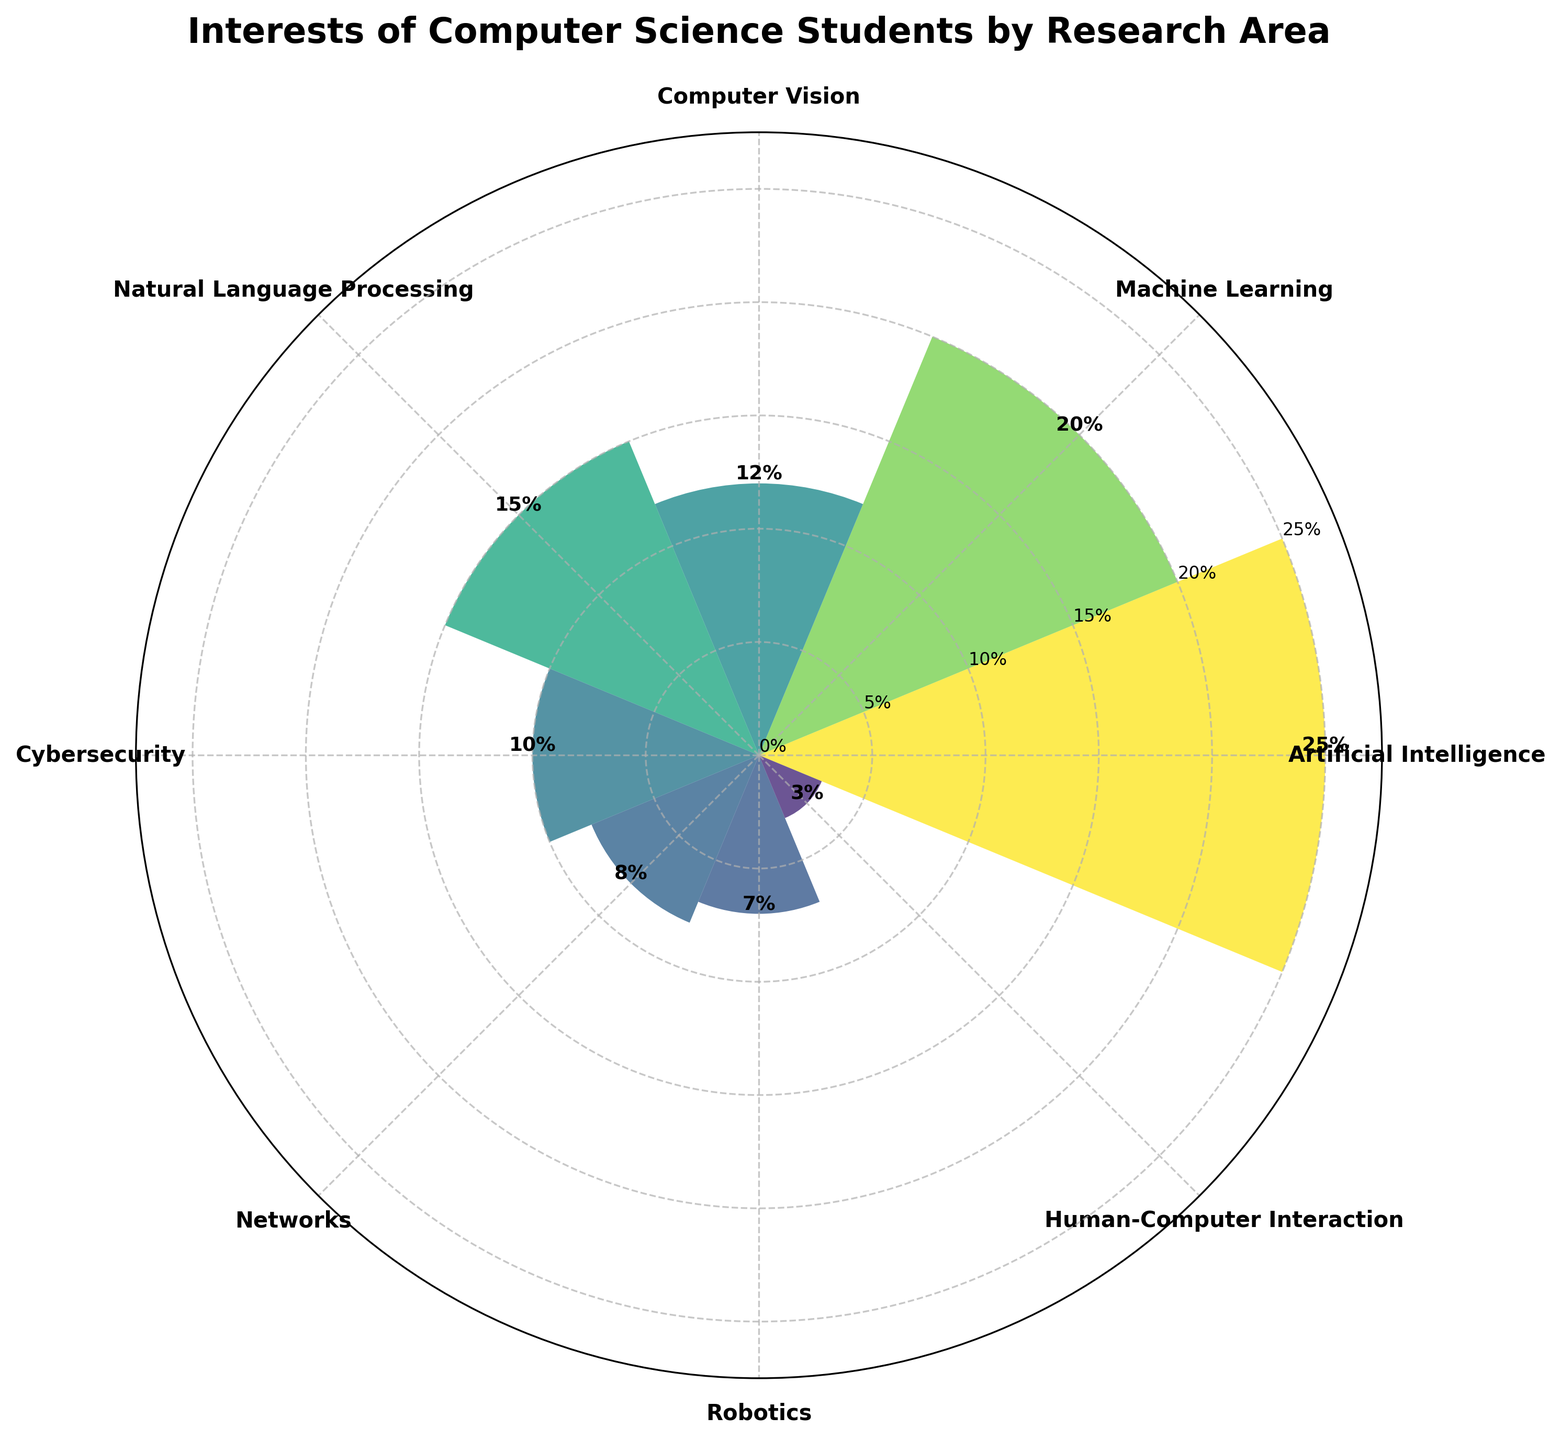What is the title of the figure? The title can be found at the top of the figure. It describes the overall topic or dataset being visualized.
Answer: Interests of Computer Science Students by Research Area How many research areas are shown in the figure? Count the number of distinct bars or sectors in the rose chart, each representing a research area.
Answer: 8 Which research area has the highest interest percentage? Identify the bar with the maximum height on the plot.
Answer: Artificial Intelligence What percentage of students are interested in Machine Learning? Find the label or text associated with the bar representing Machine Learning.
Answer: 20% What is the combined percentage of students interested in Cybersecurity and Networks? Find the percentages for Cybersecurity and Networks, then sum these percentages: 10% (Cybersecurity) + 8% (Networks).
Answer: 18% Which research area has the lowest interest percentage? Identify the bar with the minimum height on the plot.
Answer: Human-Computer Interaction What is the difference in interest percentages between Artificial Intelligence and Robotics? Calculate the difference between the percentages for Artificial Intelligence (25%) and Robotics (7%): 25% - 7%.
Answer: 18% Are more students interested in Computer Vision or Natural Language Processing? Compare the heights of the bars for Computer Vision and Natural Language Processing.
Answer: Natural Language Processing What is the average interest percentage across all research areas? Sum the percentages for all research areas and divide by the number of research areas: (25 + 20 + 12 + 15 + 10 + 8 + 7 + 3) / 8.
Answer: 12.5% Which research area has an interest percentage closest to 10%? Identify the bar whose height is nearest to 10%.
Answer: Cybersecurity 